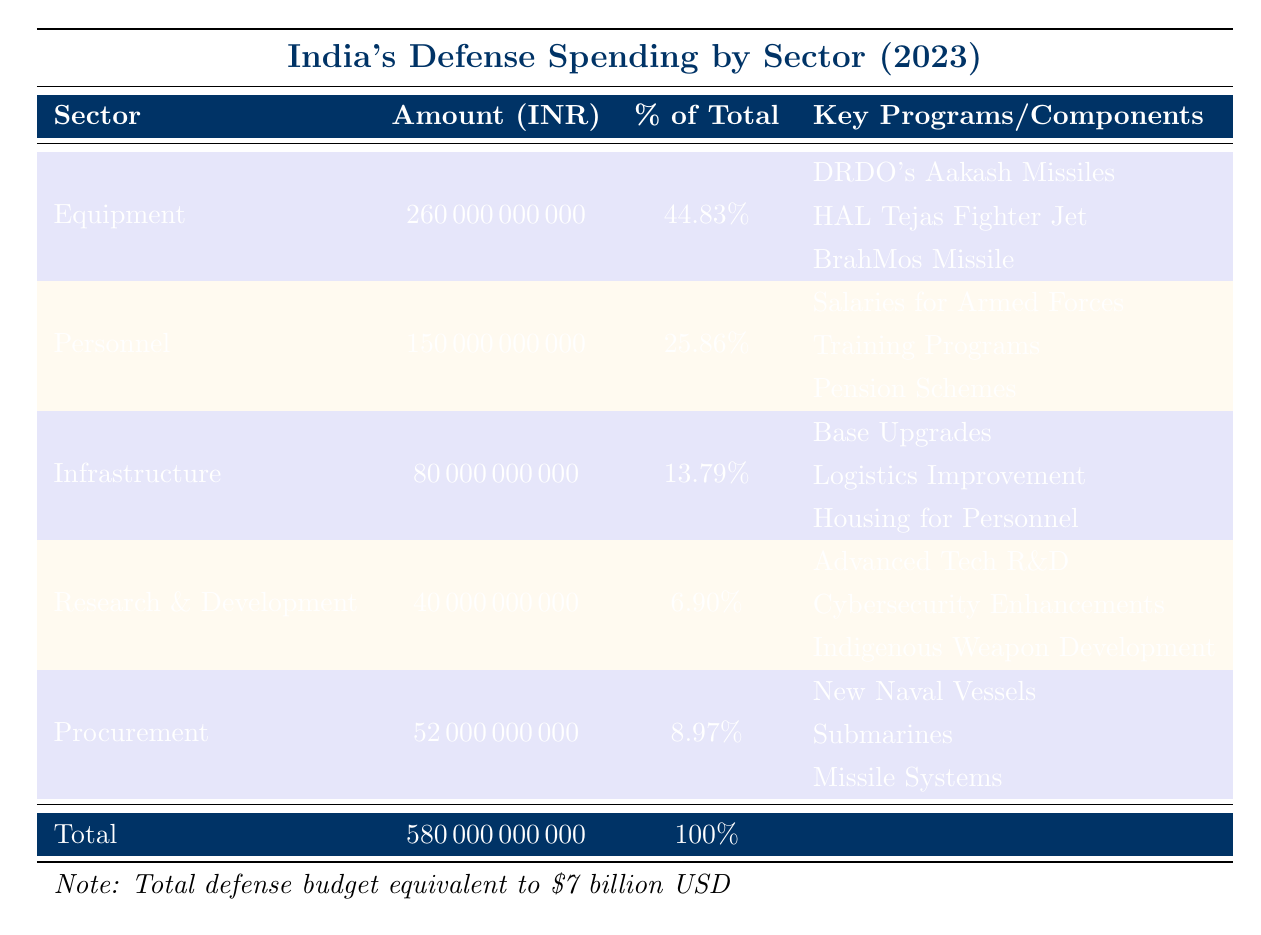What is the total defense budget for India in 2023? The table shows a row labeled "Total" under the spending categories where the total defense budget is given as 580,000,000,000 INR.
Answer: 580,000,000,000 INR What percentage of the total defense budget is allocated to equipment? The row for "Equipment" indicates that 44.83% of the total defense budget is allocated to equipment.
Answer: 44.83% How much is spent on personnel in INR? The table details that under the "Personnel" category, the amount spent is listed as 150,000,000,000 INR.
Answer: 150,000,000,000 INR What is the total amount spent on research and development? The table indicates the amount allocated for "Research & Development" is 40,000,000,000 INR.
Answer: 40,000,000,000 INR What is the combined spending on infrastructure and procurement? The amount for infrastructure is 80,000,000,000 INR and for procurement it's 52,000,000,000 INR. Adding these gives 80,000,000,000 + 52,000,000,000 = 132,000,000,000 INR.
Answer: 132,000,000,000 INR Which sector received the highest allocation in the budget, and what percentage of total spending does it represent? The "Equipment" sector received the highest allocation of 260,000,000,000 INR and represents 44.83% of the total budget.
Answer: Equipment, 44.83% True or False: More than 50% of the defense budget is spent on personnel. The table shows that spending on personnel is 150,000,000,000 INR, which is 25.86% of the total budget. Since 25.86% is less than 50%, the statement is false.
Answer: False How much budget is allocated to the Air Force compared to the Navy? The Air Force's budget is 127,200,000,000 INR, while the Navy's is 116,000,000,000 INR. Comparing these, the Air Force receives more.
Answer: Air Force receives more If the total defense budget is divided equally among the three armed forces, how much would each receive? The total budget of 580,000,000,000 INR divided by three branches is 580,000,000,000 / 3 = 193,333,333,333.33 INR.
Answer: 193,333,333,333.33 INR What proportion of the total defense budget goes to procurement versus research and development? The procurement amount is 52,000,000,000 INR and research and development is 40,000,000,000 INR. The total budget is 580,000,000,000 INR. For procurement, the percentage is (52,000,000,000 / 580,000,000,000) * 100 = 8.97%, and for R&D, it's (40,000,000,000 / 580,000,000,000) * 100 = 6.90%.
Answer: Procurement 8.97%, R&D 6.90% 